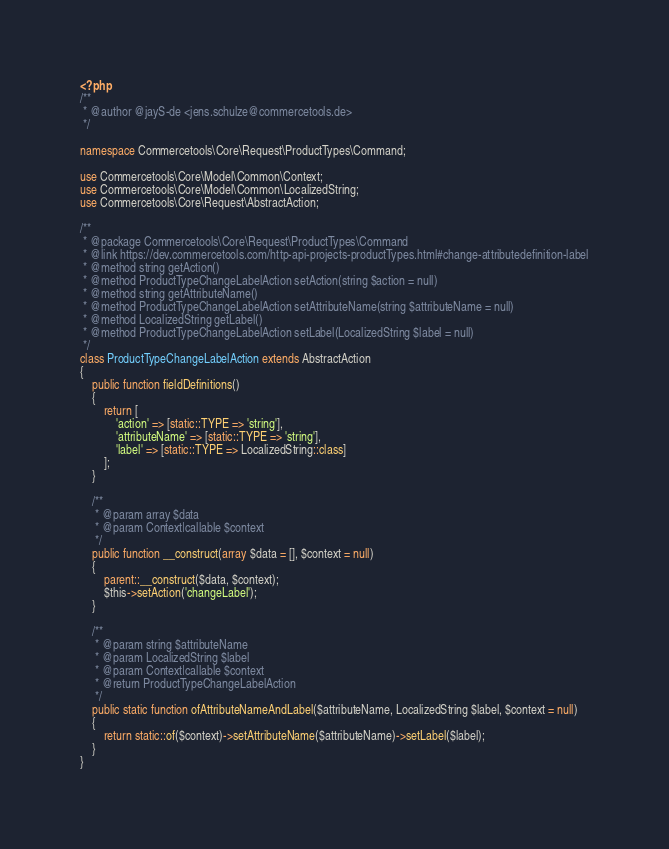Convert code to text. <code><loc_0><loc_0><loc_500><loc_500><_PHP_><?php
/**
 * @author @jayS-de <jens.schulze@commercetools.de>
 */

namespace Commercetools\Core\Request\ProductTypes\Command;

use Commercetools\Core\Model\Common\Context;
use Commercetools\Core\Model\Common\LocalizedString;
use Commercetools\Core\Request\AbstractAction;

/**
 * @package Commercetools\Core\Request\ProductTypes\Command
 * @link https://dev.commercetools.com/http-api-projects-productTypes.html#change-attributedefinition-label
 * @method string getAction()
 * @method ProductTypeChangeLabelAction setAction(string $action = null)
 * @method string getAttributeName()
 * @method ProductTypeChangeLabelAction setAttributeName(string $attributeName = null)
 * @method LocalizedString getLabel()
 * @method ProductTypeChangeLabelAction setLabel(LocalizedString $label = null)
 */
class ProductTypeChangeLabelAction extends AbstractAction
{
    public function fieldDefinitions()
    {
        return [
            'action' => [static::TYPE => 'string'],
            'attributeName' => [static::TYPE => 'string'],
            'label' => [static::TYPE => LocalizedString::class]
        ];
    }

    /**
     * @param array $data
     * @param Context|callable $context
     */
    public function __construct(array $data = [], $context = null)
    {
        parent::__construct($data, $context);
        $this->setAction('changeLabel');
    }

    /**
     * @param string $attributeName
     * @param LocalizedString $label
     * @param Context|callable $context
     * @return ProductTypeChangeLabelAction
     */
    public static function ofAttributeNameAndLabel($attributeName, LocalizedString $label, $context = null)
    {
        return static::of($context)->setAttributeName($attributeName)->setLabel($label);
    }
}
</code> 